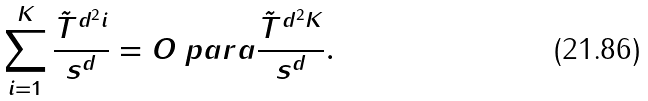Convert formula to latex. <formula><loc_0><loc_0><loc_500><loc_500>\sum _ { i = 1 } ^ { K } \frac { \tilde { T } ^ { d ^ { 2 } i } } { s ^ { d } } = O \ p a r a { \frac { \tilde { T } ^ { d ^ { 2 } K } } { s ^ { d } } } .</formula> 